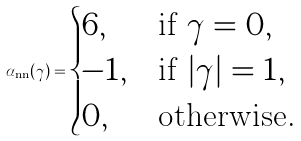Convert formula to latex. <formula><loc_0><loc_0><loc_500><loc_500>\alpha _ { \text {nn} } ( \gamma ) = \begin{cases} 6 , & \text {if } \gamma = 0 , \\ - 1 , & \text {if } | \gamma | = 1 , \\ 0 , & \text {otherwise.} \end{cases}</formula> 